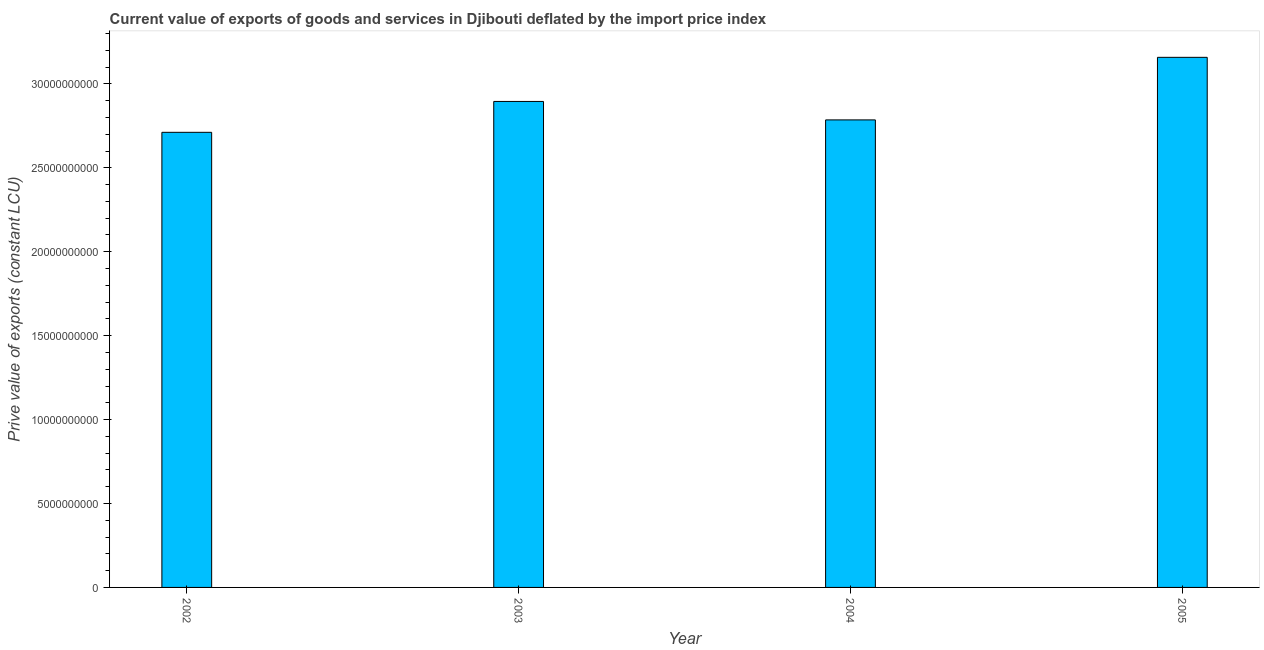Does the graph contain grids?
Provide a short and direct response. No. What is the title of the graph?
Give a very brief answer. Current value of exports of goods and services in Djibouti deflated by the import price index. What is the label or title of the Y-axis?
Keep it short and to the point. Prive value of exports (constant LCU). What is the price value of exports in 2004?
Give a very brief answer. 2.79e+1. Across all years, what is the maximum price value of exports?
Your answer should be very brief. 3.16e+1. Across all years, what is the minimum price value of exports?
Make the answer very short. 2.71e+1. What is the sum of the price value of exports?
Give a very brief answer. 1.16e+11. What is the difference between the price value of exports in 2003 and 2004?
Your response must be concise. 1.10e+09. What is the average price value of exports per year?
Provide a short and direct response. 2.89e+1. What is the median price value of exports?
Your response must be concise. 2.84e+1. What is the ratio of the price value of exports in 2003 to that in 2004?
Ensure brevity in your answer.  1.04. Is the difference between the price value of exports in 2002 and 2005 greater than the difference between any two years?
Your answer should be compact. Yes. What is the difference between the highest and the second highest price value of exports?
Provide a short and direct response. 2.63e+09. Is the sum of the price value of exports in 2002 and 2004 greater than the maximum price value of exports across all years?
Your answer should be compact. Yes. What is the difference between the highest and the lowest price value of exports?
Your answer should be very brief. 4.47e+09. In how many years, is the price value of exports greater than the average price value of exports taken over all years?
Your answer should be very brief. 2. How many years are there in the graph?
Keep it short and to the point. 4. What is the difference between two consecutive major ticks on the Y-axis?
Your answer should be very brief. 5.00e+09. Are the values on the major ticks of Y-axis written in scientific E-notation?
Ensure brevity in your answer.  No. What is the Prive value of exports (constant LCU) of 2002?
Make the answer very short. 2.71e+1. What is the Prive value of exports (constant LCU) of 2003?
Your answer should be compact. 2.90e+1. What is the Prive value of exports (constant LCU) in 2004?
Keep it short and to the point. 2.79e+1. What is the Prive value of exports (constant LCU) of 2005?
Provide a short and direct response. 3.16e+1. What is the difference between the Prive value of exports (constant LCU) in 2002 and 2003?
Give a very brief answer. -1.84e+09. What is the difference between the Prive value of exports (constant LCU) in 2002 and 2004?
Offer a terse response. -7.40e+08. What is the difference between the Prive value of exports (constant LCU) in 2002 and 2005?
Provide a succinct answer. -4.47e+09. What is the difference between the Prive value of exports (constant LCU) in 2003 and 2004?
Your answer should be very brief. 1.10e+09. What is the difference between the Prive value of exports (constant LCU) in 2003 and 2005?
Offer a very short reply. -2.63e+09. What is the difference between the Prive value of exports (constant LCU) in 2004 and 2005?
Give a very brief answer. -3.73e+09. What is the ratio of the Prive value of exports (constant LCU) in 2002 to that in 2003?
Provide a short and direct response. 0.94. What is the ratio of the Prive value of exports (constant LCU) in 2002 to that in 2004?
Your answer should be compact. 0.97. What is the ratio of the Prive value of exports (constant LCU) in 2002 to that in 2005?
Keep it short and to the point. 0.86. What is the ratio of the Prive value of exports (constant LCU) in 2003 to that in 2004?
Make the answer very short. 1.04. What is the ratio of the Prive value of exports (constant LCU) in 2003 to that in 2005?
Provide a succinct answer. 0.92. What is the ratio of the Prive value of exports (constant LCU) in 2004 to that in 2005?
Your response must be concise. 0.88. 